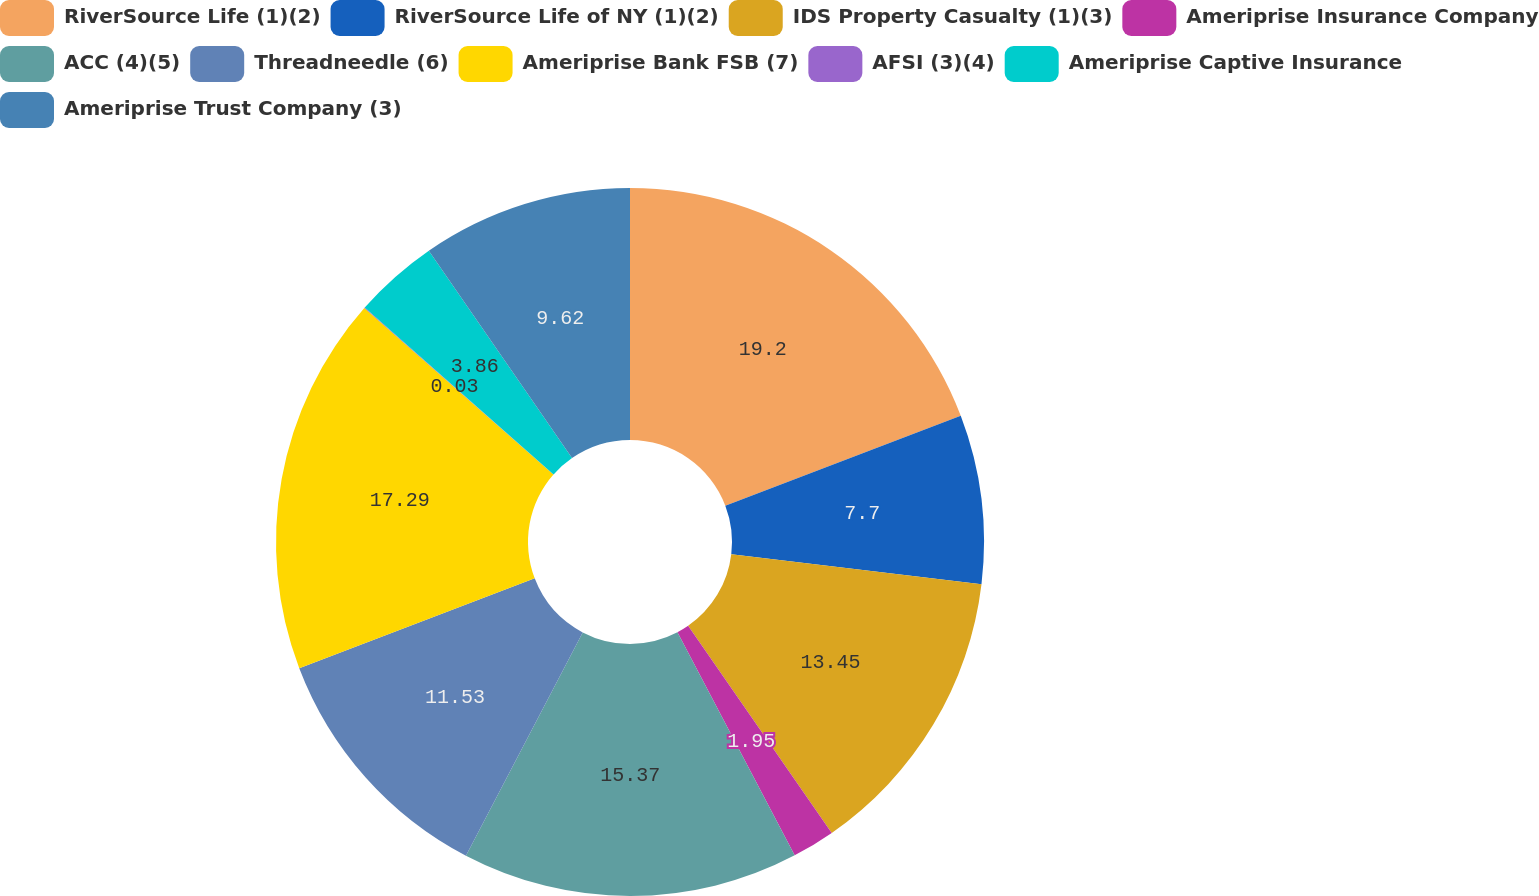Convert chart to OTSL. <chart><loc_0><loc_0><loc_500><loc_500><pie_chart><fcel>RiverSource Life (1)(2)<fcel>RiverSource Life of NY (1)(2)<fcel>IDS Property Casualty (1)(3)<fcel>Ameriprise Insurance Company<fcel>ACC (4)(5)<fcel>Threadneedle (6)<fcel>Ameriprise Bank FSB (7)<fcel>AFSI (3)(4)<fcel>Ameriprise Captive Insurance<fcel>Ameriprise Trust Company (3)<nl><fcel>19.2%<fcel>7.7%<fcel>13.45%<fcel>1.95%<fcel>15.37%<fcel>11.53%<fcel>17.29%<fcel>0.03%<fcel>3.86%<fcel>9.62%<nl></chart> 